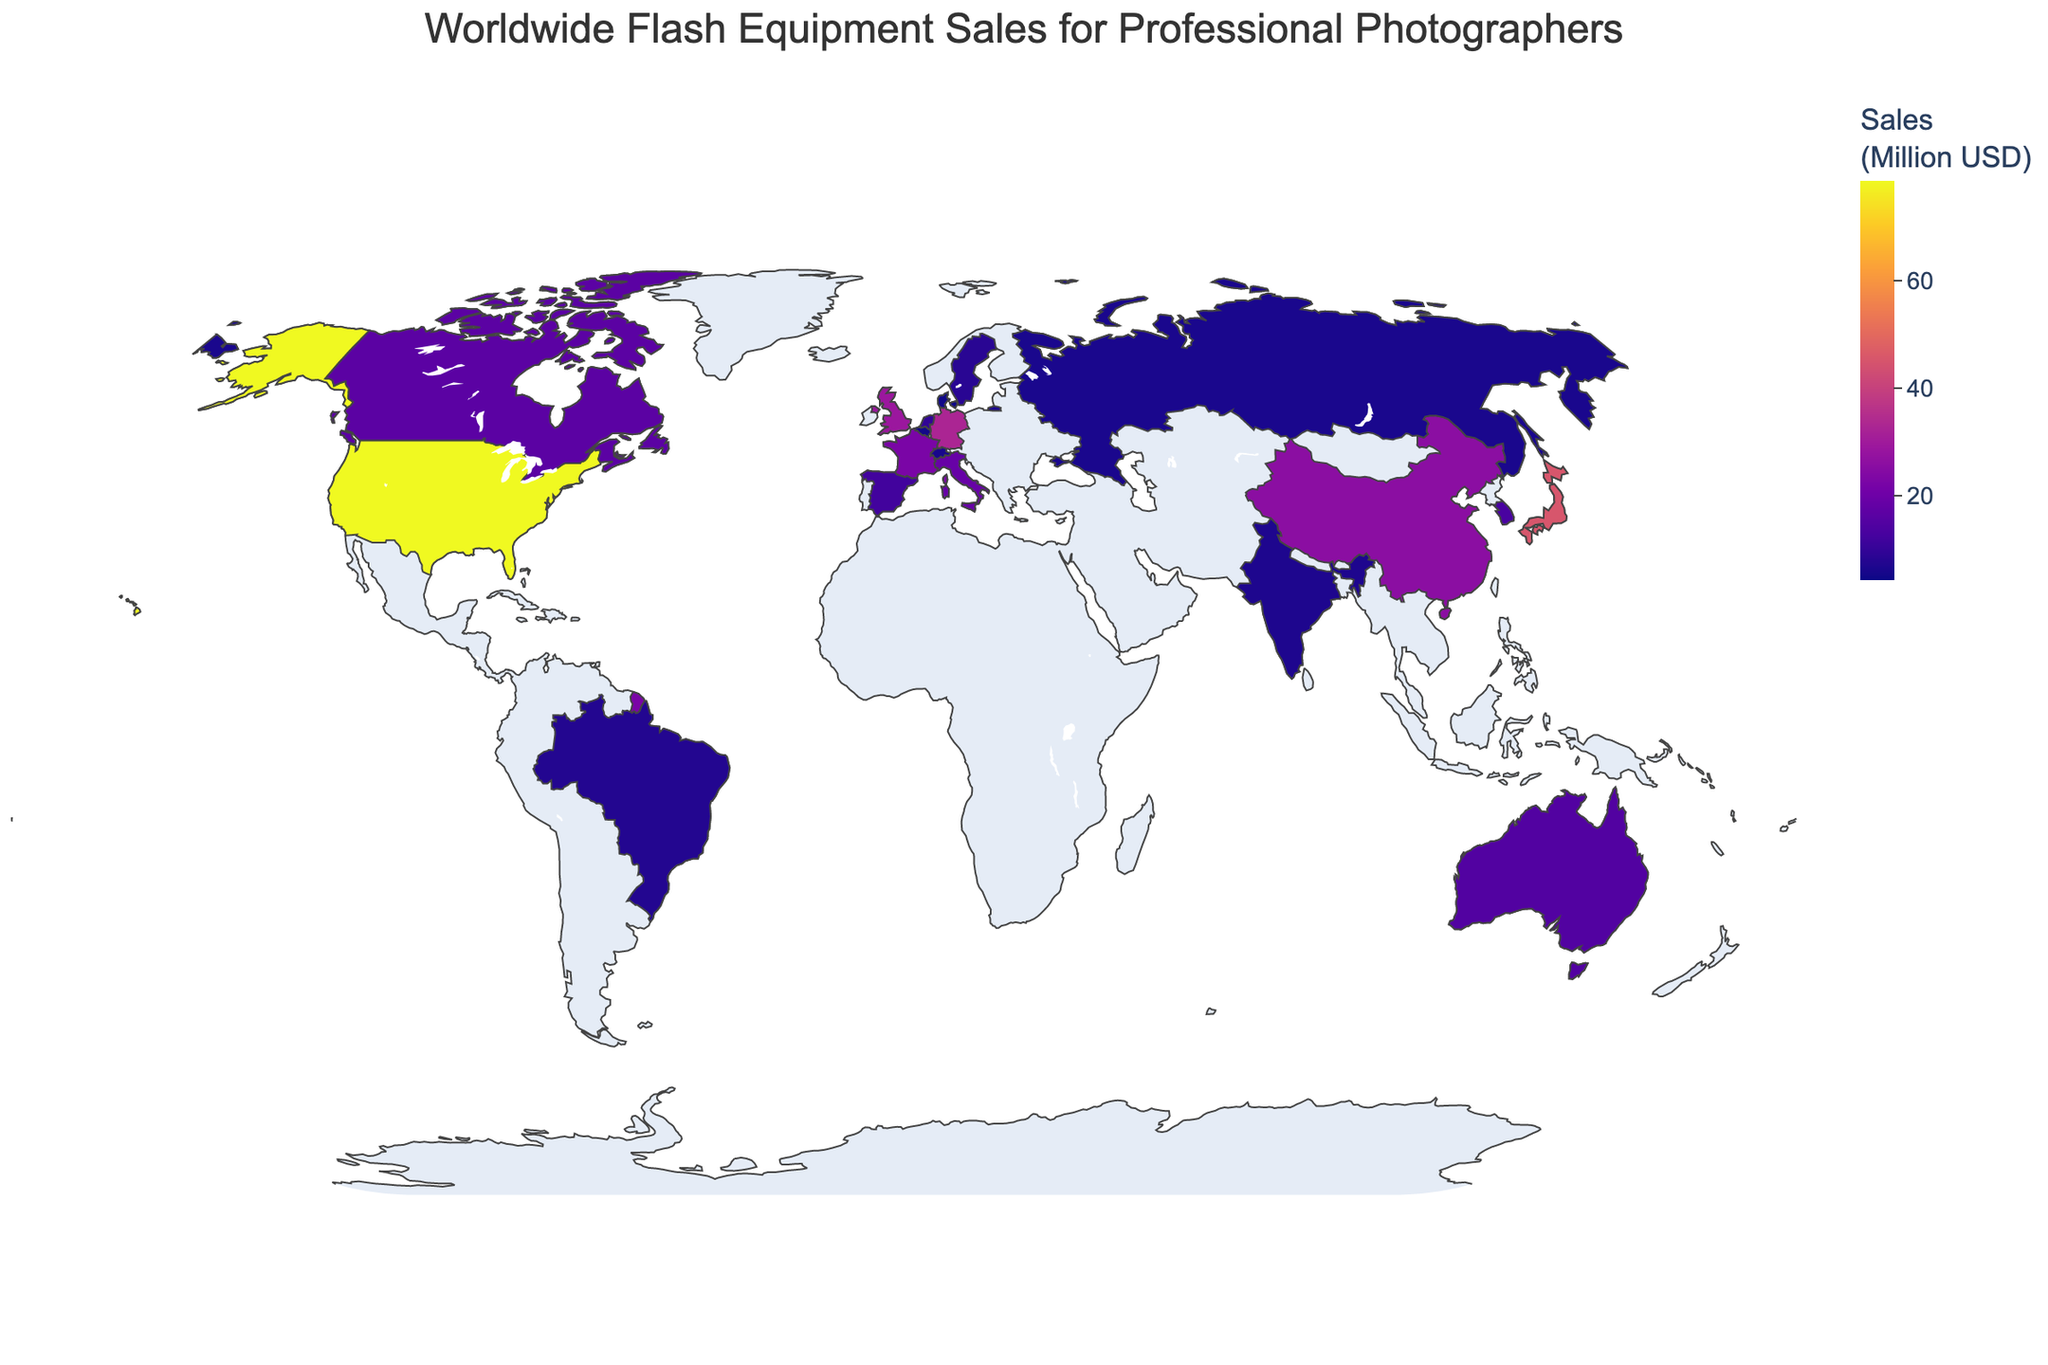What's the title of the figure? The title is prominently displayed at the top of the figure, which helps identify the purpose of the plot.
Answer: Worldwide Flash Equipment Sales for Professional Photographers Which country has the highest sales of flash equipment? By looking at the plot, the country with the highest sales value is colored the darkest.
Answer: United States What is the difference in sales between Japan and Germany? The sales in Japan are 45.2 million USD, and the sales in Germany are 32.7 million USD. The difference can be calculated by subtracting German sales from Japanese sales. 45.2 - 32.7 = 12.5
Answer: 12.5 million USD What is the average sales of flash equipment in the top 5 countries? To find the average, sum the sales values of the top 5 countries and divide by 5. The top 5 countries are the United States (78.5), Japan (45.2), Germany (32.7), the United Kingdom (28.9), and China (25.6). The sum is 78.5 + 45.2 + 32.7 + 28.9 + 25.6 = 210.9, and the average is 210.9 / 5.
Answer: 42.18 million USD Which country has the lowest sales among those shown in the plot? The country with the lowest sales value will be colored the lightest on the map.
Answer: Singapore How do the flash equipment sales in France compare with those in Italy? Sales in France are 22.3 million USD, while in Italy, it is 18.7 million USD. France has higher sales than Italy.
Answer: France has higher sales What is the combined sales value of the United Kingdom and Canada? The sales in the United Kingdom are 28.9 million USD, and in Canada, they are 16.4 million USD. The combined value is 28.9 + 16.4 = 45.3 million USD.
Answer: 45.3 million USD How much more sales does the United States have compared to China? The sales in the United States are 78.5 million USD, and in China, it is 25.6 million USD. The difference is calculated by subtracting China's sales from the United States. 78.5 - 25.6 = 52.9
Answer: 52.9 million USD Which countries have sales between 10 and 20 million USD? The countries within this sales range can be identified by their coloring and hover information on the plot. They are Spain (11.9), Netherlands (9.6), Sweden (8.3), Brazil (7.5), India (6.8), Russia (6.2), Switzerland (5.9), Belgium (5.1), Denmark (4.7), and Singapore (4.3).
Answer: Spain, Netherlands, Sweden, Brazil, India, Russia, Switzerland, Belgium, Denmark, Singapore Which continent appears to have the highest density of high flash equipment sales? By observing the map, pick the continent with multiple countries having high sales values. North America, with the United States and Canada, appears to have high sales density.
Answer: North America 